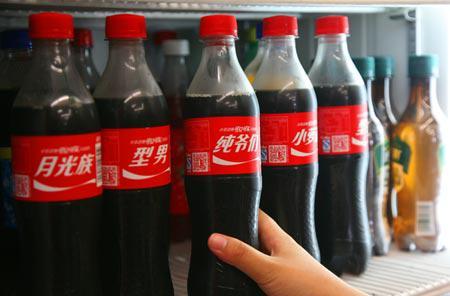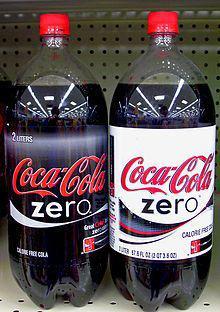The first image is the image on the left, the second image is the image on the right. Analyze the images presented: Is the assertion "IN at least one image there is a display case of at least two shelves holding  sodas." valid? Answer yes or no. No. The first image is the image on the left, the second image is the image on the right. Evaluate the accuracy of this statement regarding the images: "There are at most four bottles of soda in one of the images.". Is it true? Answer yes or no. Yes. 